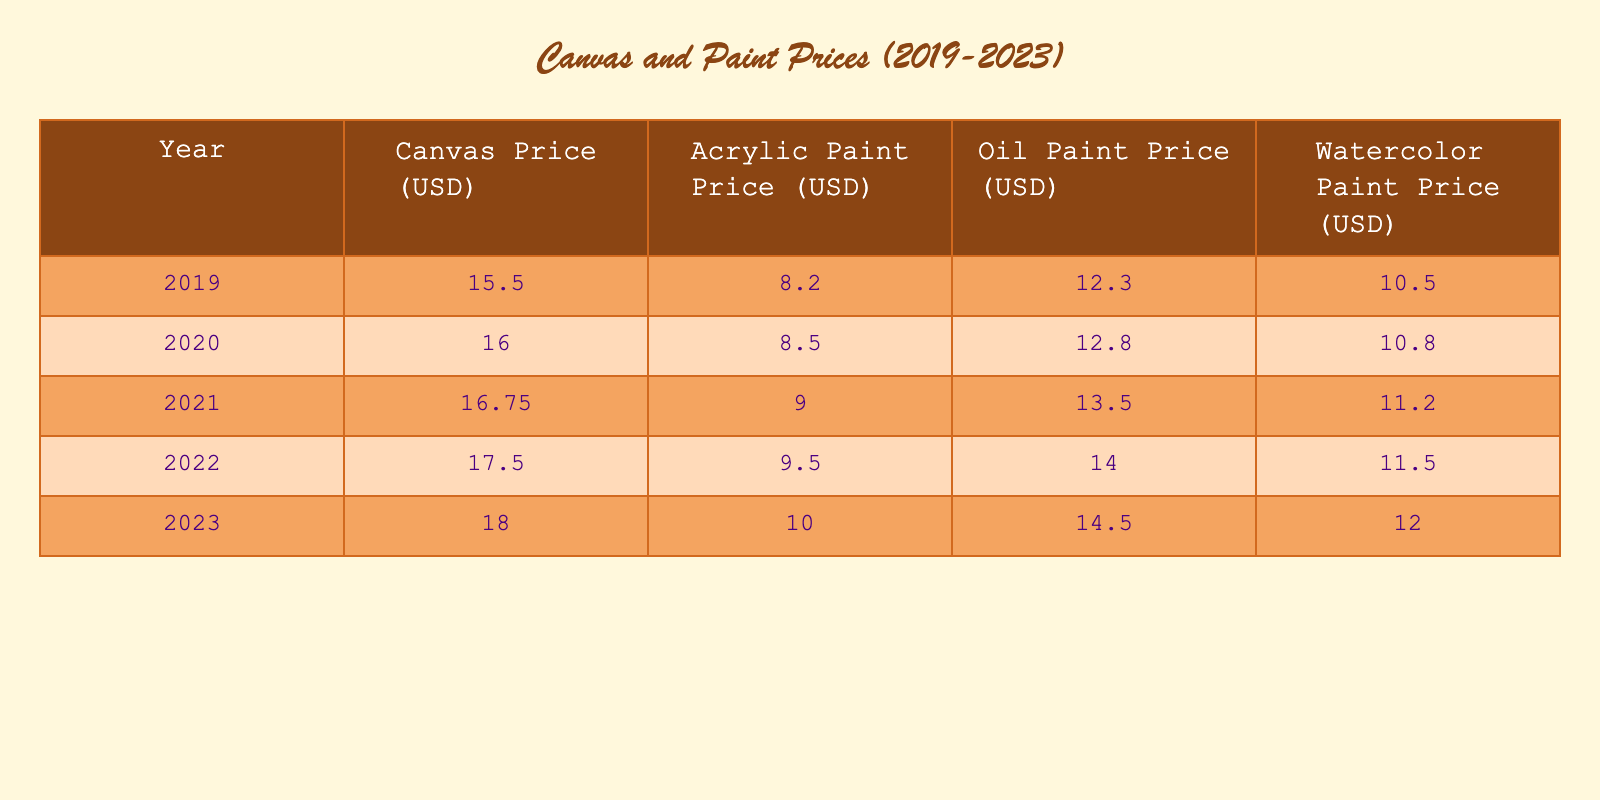What was the canvas price in 2021? The table lists the canvas price for each year. From the row corresponding to the year 2021, the canvas price is 16.75 USD.
Answer: 16.75 USD Which type of paint had the highest price in 2023? In the 2023 row of the table, the prices for the different paint types are listed as follows: Acrylic Paint (10.00 USD), Oil Paint (14.50 USD), Watercolor Paint (12.00 USD). The Oil Paint price is the highest among them.
Answer: Oil Paint What was the average price trend of watercolor paint from 2019 to 2023? The watercolor paint prices over the years are: 10.50 (2019), 10.80 (2020), 11.20 (2021), 11.50 (2022), 12.00 (2023). The average can be calculated as (10.50 + 10.80 + 11.20 + 11.50 + 12.00) / 5 = 11.20. Therefore, the average price is 11.20 USD.
Answer: 11.20 USD Did canvas prices increase every year from 2019 to 2023? By examining the canvas prices year by year: 15.50 (2019), 16.00 (2020), 16.75 (2021), 17.50 (2022), 18.00 (2023), it can be noted that each price increased compared to the previous year. Therefore, yes, the prices did increase every year.
Answer: Yes What was the percentage increase in acrylic paint price from 2019 to 2023? The acrylic paint prices are 8.20 (2019) and 10.00 (2023). The increase can be calculated as (10.00 - 8.20) = 1.80. The percentage increase is (1.80 / 8.20) * 100 = approximately 21.95%.
Answer: Approximately 21.95% 